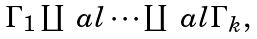<formula> <loc_0><loc_0><loc_500><loc_500>\begin{array} { l l } \Gamma _ { 1 } \coprod _ { \ } a l \cdots \coprod _ { \ } a l \Gamma _ { k } , \end{array}</formula> 